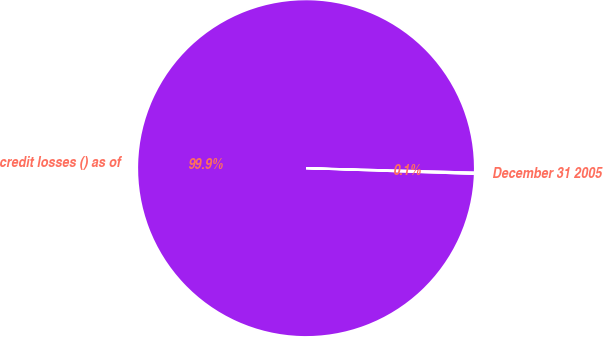Convert chart to OTSL. <chart><loc_0><loc_0><loc_500><loc_500><pie_chart><fcel>credit losses () as of<fcel>December 31 2005<nl><fcel>99.87%<fcel>0.13%<nl></chart> 